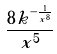<formula> <loc_0><loc_0><loc_500><loc_500>\frac { 8 k ^ { - \frac { 1 } { x ^ { 8 } } } } { x ^ { 5 } }</formula> 